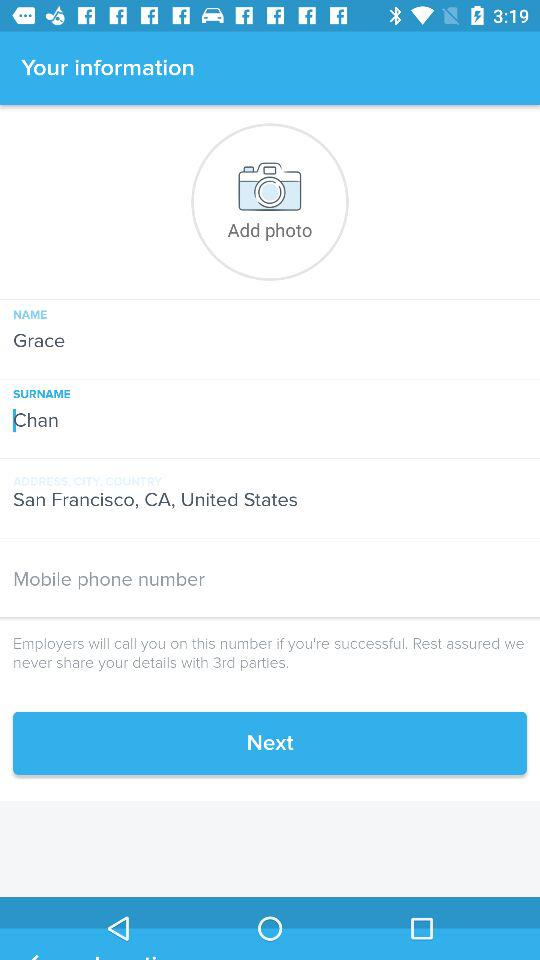What is the address? The address is San Francisco, CA, United States. 